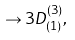<formula> <loc_0><loc_0><loc_500><loc_500>\rightarrow 3 D _ { ( 1 ) } ^ { ( 3 ) } ,</formula> 